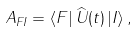Convert formula to latex. <formula><loc_0><loc_0><loc_500><loc_500>A _ { F I } = \left \langle F \right | \widehat { U } ( t ) \left | I \right \rangle ,</formula> 